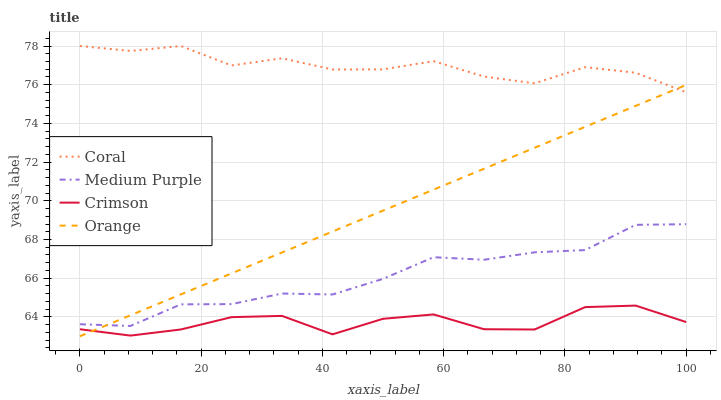Does Crimson have the minimum area under the curve?
Answer yes or no. Yes. Does Coral have the maximum area under the curve?
Answer yes or no. Yes. Does Coral have the minimum area under the curve?
Answer yes or no. No. Does Crimson have the maximum area under the curve?
Answer yes or no. No. Is Orange the smoothest?
Answer yes or no. Yes. Is Crimson the roughest?
Answer yes or no. Yes. Is Coral the smoothest?
Answer yes or no. No. Is Coral the roughest?
Answer yes or no. No. Does Crimson have the lowest value?
Answer yes or no. No. Does Coral have the highest value?
Answer yes or no. Yes. Does Crimson have the highest value?
Answer yes or no. No. Is Medium Purple less than Coral?
Answer yes or no. Yes. Is Coral greater than Crimson?
Answer yes or no. Yes. Does Medium Purple intersect Coral?
Answer yes or no. No. 